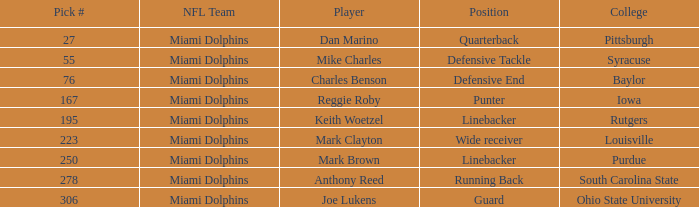Which Player has a Pick # lower than 223 and a Defensive End Position? Charles Benson. 